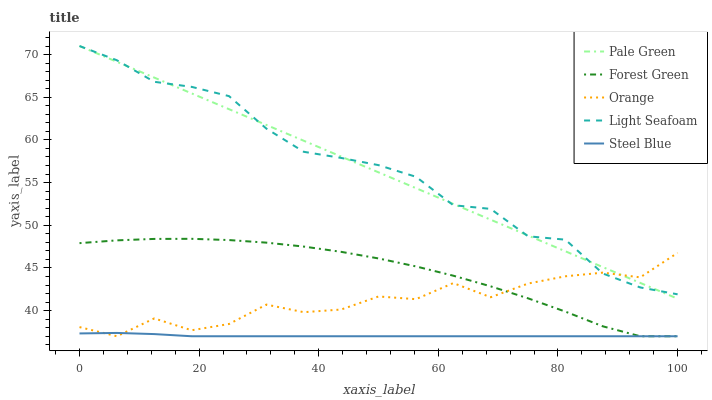Does Steel Blue have the minimum area under the curve?
Answer yes or no. Yes. Does Light Seafoam have the maximum area under the curve?
Answer yes or no. Yes. Does Forest Green have the minimum area under the curve?
Answer yes or no. No. Does Forest Green have the maximum area under the curve?
Answer yes or no. No. Is Pale Green the smoothest?
Answer yes or no. Yes. Is Orange the roughest?
Answer yes or no. Yes. Is Forest Green the smoothest?
Answer yes or no. No. Is Forest Green the roughest?
Answer yes or no. No. Does Pale Green have the lowest value?
Answer yes or no. No. Does Light Seafoam have the highest value?
Answer yes or no. Yes. Does Forest Green have the highest value?
Answer yes or no. No. Is Steel Blue less than Pale Green?
Answer yes or no. Yes. Is Pale Green greater than Forest Green?
Answer yes or no. Yes. Does Pale Green intersect Orange?
Answer yes or no. Yes. Is Pale Green less than Orange?
Answer yes or no. No. Is Pale Green greater than Orange?
Answer yes or no. No. Does Steel Blue intersect Pale Green?
Answer yes or no. No. 